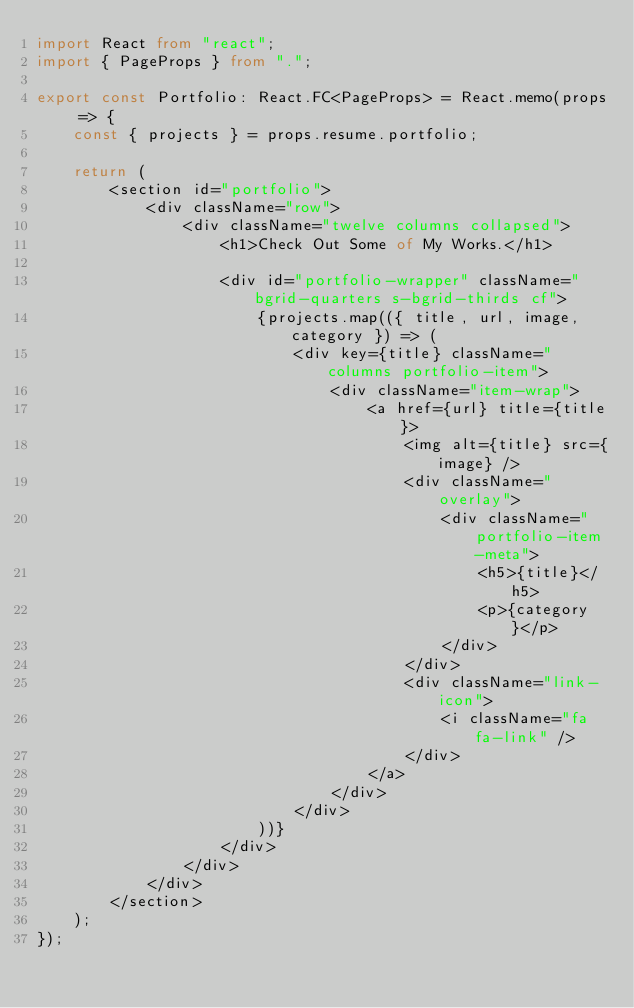<code> <loc_0><loc_0><loc_500><loc_500><_TypeScript_>import React from "react";
import { PageProps } from ".";

export const Portfolio: React.FC<PageProps> = React.memo(props => {
    const { projects } = props.resume.portfolio;

    return (
        <section id="portfolio">
            <div className="row">
                <div className="twelve columns collapsed">
                    <h1>Check Out Some of My Works.</h1>

                    <div id="portfolio-wrapper" className="bgrid-quarters s-bgrid-thirds cf">
                        {projects.map(({ title, url, image, category }) => (
                            <div key={title} className="columns portfolio-item">
                                <div className="item-wrap">
                                    <a href={url} title={title}>
                                        <img alt={title} src={image} />
                                        <div className="overlay">
                                            <div className="portfolio-item-meta">
                                                <h5>{title}</h5>
                                                <p>{category}</p>
                                            </div>
                                        </div>
                                        <div className="link-icon">
                                            <i className="fa fa-link" />
                                        </div>
                                    </a>
                                </div>
                            </div>
                        ))}
                    </div>
                </div>
            </div>
        </section>
    );
});
</code> 